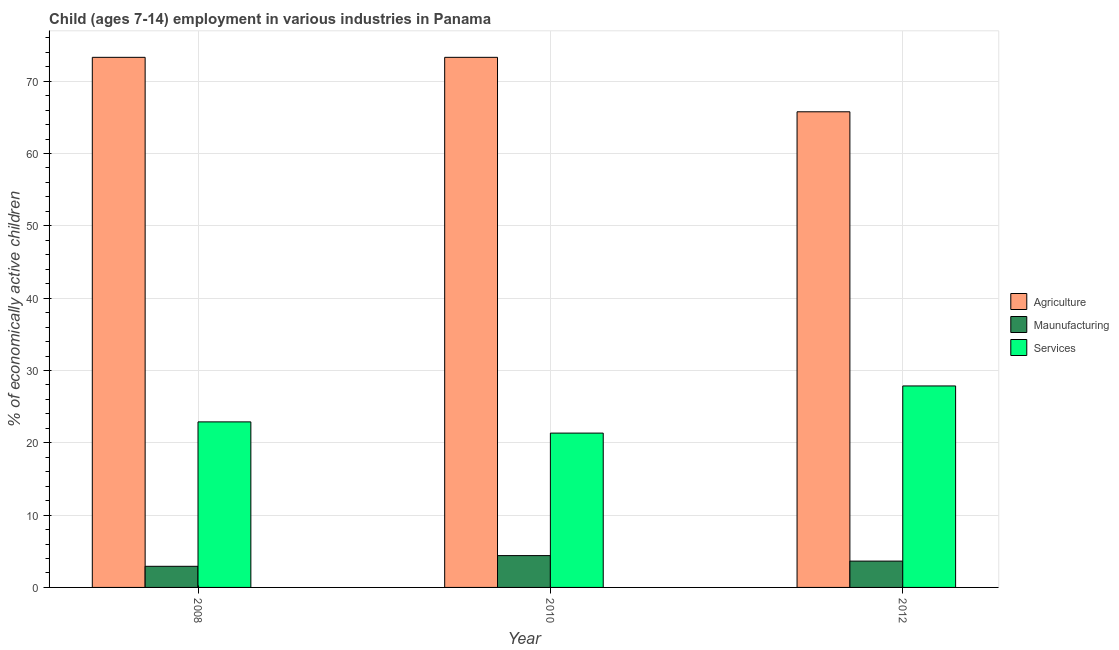How many groups of bars are there?
Your response must be concise. 3. Are the number of bars per tick equal to the number of legend labels?
Offer a terse response. Yes. How many bars are there on the 1st tick from the left?
Provide a short and direct response. 3. In how many cases, is the number of bars for a given year not equal to the number of legend labels?
Provide a succinct answer. 0. What is the percentage of economically active children in agriculture in 2008?
Offer a terse response. 73.3. Across all years, what is the maximum percentage of economically active children in services?
Offer a terse response. 27.86. Across all years, what is the minimum percentage of economically active children in agriculture?
Offer a terse response. 65.77. In which year was the percentage of economically active children in agriculture maximum?
Your answer should be compact. 2008. What is the total percentage of economically active children in services in the graph?
Your answer should be very brief. 72.09. What is the difference between the percentage of economically active children in agriculture in 2010 and the percentage of economically active children in services in 2012?
Your answer should be very brief. 7.53. What is the average percentage of economically active children in services per year?
Your answer should be very brief. 24.03. What is the ratio of the percentage of economically active children in services in 2008 to that in 2010?
Ensure brevity in your answer.  1.07. Is the difference between the percentage of economically active children in manufacturing in 2008 and 2012 greater than the difference between the percentage of economically active children in services in 2008 and 2012?
Offer a terse response. No. What is the difference between the highest and the lowest percentage of economically active children in agriculture?
Provide a short and direct response. 7.53. What does the 1st bar from the left in 2012 represents?
Provide a short and direct response. Agriculture. What does the 3rd bar from the right in 2010 represents?
Ensure brevity in your answer.  Agriculture. Are all the bars in the graph horizontal?
Your answer should be very brief. No. What is the difference between two consecutive major ticks on the Y-axis?
Ensure brevity in your answer.  10. Does the graph contain any zero values?
Your answer should be very brief. No. Does the graph contain grids?
Give a very brief answer. Yes. What is the title of the graph?
Make the answer very short. Child (ages 7-14) employment in various industries in Panama. Does "Industrial Nitrous Oxide" appear as one of the legend labels in the graph?
Ensure brevity in your answer.  No. What is the label or title of the Y-axis?
Give a very brief answer. % of economically active children. What is the % of economically active children in Agriculture in 2008?
Offer a very short reply. 73.3. What is the % of economically active children of Maunufacturing in 2008?
Provide a succinct answer. 2.92. What is the % of economically active children of Services in 2008?
Ensure brevity in your answer.  22.89. What is the % of economically active children of Agriculture in 2010?
Keep it short and to the point. 73.3. What is the % of economically active children in Services in 2010?
Your answer should be compact. 21.34. What is the % of economically active children in Agriculture in 2012?
Your answer should be compact. 65.77. What is the % of economically active children of Maunufacturing in 2012?
Keep it short and to the point. 3.64. What is the % of economically active children in Services in 2012?
Your answer should be very brief. 27.86. Across all years, what is the maximum % of economically active children in Agriculture?
Keep it short and to the point. 73.3. Across all years, what is the maximum % of economically active children of Services?
Your answer should be compact. 27.86. Across all years, what is the minimum % of economically active children of Agriculture?
Make the answer very short. 65.77. Across all years, what is the minimum % of economically active children in Maunufacturing?
Provide a short and direct response. 2.92. Across all years, what is the minimum % of economically active children in Services?
Keep it short and to the point. 21.34. What is the total % of economically active children of Agriculture in the graph?
Make the answer very short. 212.37. What is the total % of economically active children of Maunufacturing in the graph?
Your answer should be compact. 10.96. What is the total % of economically active children in Services in the graph?
Provide a succinct answer. 72.09. What is the difference between the % of economically active children in Agriculture in 2008 and that in 2010?
Make the answer very short. 0. What is the difference between the % of economically active children of Maunufacturing in 2008 and that in 2010?
Your response must be concise. -1.48. What is the difference between the % of economically active children in Services in 2008 and that in 2010?
Make the answer very short. 1.55. What is the difference between the % of economically active children in Agriculture in 2008 and that in 2012?
Your answer should be very brief. 7.53. What is the difference between the % of economically active children in Maunufacturing in 2008 and that in 2012?
Give a very brief answer. -0.72. What is the difference between the % of economically active children of Services in 2008 and that in 2012?
Your response must be concise. -4.97. What is the difference between the % of economically active children in Agriculture in 2010 and that in 2012?
Your answer should be very brief. 7.53. What is the difference between the % of economically active children of Maunufacturing in 2010 and that in 2012?
Offer a terse response. 0.76. What is the difference between the % of economically active children of Services in 2010 and that in 2012?
Your response must be concise. -6.52. What is the difference between the % of economically active children of Agriculture in 2008 and the % of economically active children of Maunufacturing in 2010?
Your answer should be very brief. 68.9. What is the difference between the % of economically active children in Agriculture in 2008 and the % of economically active children in Services in 2010?
Provide a short and direct response. 51.96. What is the difference between the % of economically active children in Maunufacturing in 2008 and the % of economically active children in Services in 2010?
Keep it short and to the point. -18.42. What is the difference between the % of economically active children in Agriculture in 2008 and the % of economically active children in Maunufacturing in 2012?
Ensure brevity in your answer.  69.66. What is the difference between the % of economically active children in Agriculture in 2008 and the % of economically active children in Services in 2012?
Provide a short and direct response. 45.44. What is the difference between the % of economically active children in Maunufacturing in 2008 and the % of economically active children in Services in 2012?
Provide a short and direct response. -24.94. What is the difference between the % of economically active children of Agriculture in 2010 and the % of economically active children of Maunufacturing in 2012?
Your answer should be very brief. 69.66. What is the difference between the % of economically active children of Agriculture in 2010 and the % of economically active children of Services in 2012?
Offer a very short reply. 45.44. What is the difference between the % of economically active children in Maunufacturing in 2010 and the % of economically active children in Services in 2012?
Offer a very short reply. -23.46. What is the average % of economically active children of Agriculture per year?
Offer a terse response. 70.79. What is the average % of economically active children of Maunufacturing per year?
Keep it short and to the point. 3.65. What is the average % of economically active children of Services per year?
Keep it short and to the point. 24.03. In the year 2008, what is the difference between the % of economically active children in Agriculture and % of economically active children in Maunufacturing?
Offer a very short reply. 70.38. In the year 2008, what is the difference between the % of economically active children in Agriculture and % of economically active children in Services?
Make the answer very short. 50.41. In the year 2008, what is the difference between the % of economically active children in Maunufacturing and % of economically active children in Services?
Offer a terse response. -19.97. In the year 2010, what is the difference between the % of economically active children of Agriculture and % of economically active children of Maunufacturing?
Give a very brief answer. 68.9. In the year 2010, what is the difference between the % of economically active children in Agriculture and % of economically active children in Services?
Provide a succinct answer. 51.96. In the year 2010, what is the difference between the % of economically active children of Maunufacturing and % of economically active children of Services?
Offer a terse response. -16.94. In the year 2012, what is the difference between the % of economically active children of Agriculture and % of economically active children of Maunufacturing?
Keep it short and to the point. 62.13. In the year 2012, what is the difference between the % of economically active children in Agriculture and % of economically active children in Services?
Provide a short and direct response. 37.91. In the year 2012, what is the difference between the % of economically active children of Maunufacturing and % of economically active children of Services?
Your response must be concise. -24.22. What is the ratio of the % of economically active children of Agriculture in 2008 to that in 2010?
Provide a succinct answer. 1. What is the ratio of the % of economically active children in Maunufacturing in 2008 to that in 2010?
Provide a succinct answer. 0.66. What is the ratio of the % of economically active children of Services in 2008 to that in 2010?
Your response must be concise. 1.07. What is the ratio of the % of economically active children in Agriculture in 2008 to that in 2012?
Ensure brevity in your answer.  1.11. What is the ratio of the % of economically active children of Maunufacturing in 2008 to that in 2012?
Make the answer very short. 0.8. What is the ratio of the % of economically active children of Services in 2008 to that in 2012?
Make the answer very short. 0.82. What is the ratio of the % of economically active children of Agriculture in 2010 to that in 2012?
Your answer should be compact. 1.11. What is the ratio of the % of economically active children in Maunufacturing in 2010 to that in 2012?
Provide a succinct answer. 1.21. What is the ratio of the % of economically active children in Services in 2010 to that in 2012?
Your answer should be compact. 0.77. What is the difference between the highest and the second highest % of economically active children in Maunufacturing?
Provide a succinct answer. 0.76. What is the difference between the highest and the second highest % of economically active children in Services?
Provide a succinct answer. 4.97. What is the difference between the highest and the lowest % of economically active children of Agriculture?
Provide a succinct answer. 7.53. What is the difference between the highest and the lowest % of economically active children in Maunufacturing?
Your answer should be compact. 1.48. What is the difference between the highest and the lowest % of economically active children in Services?
Keep it short and to the point. 6.52. 